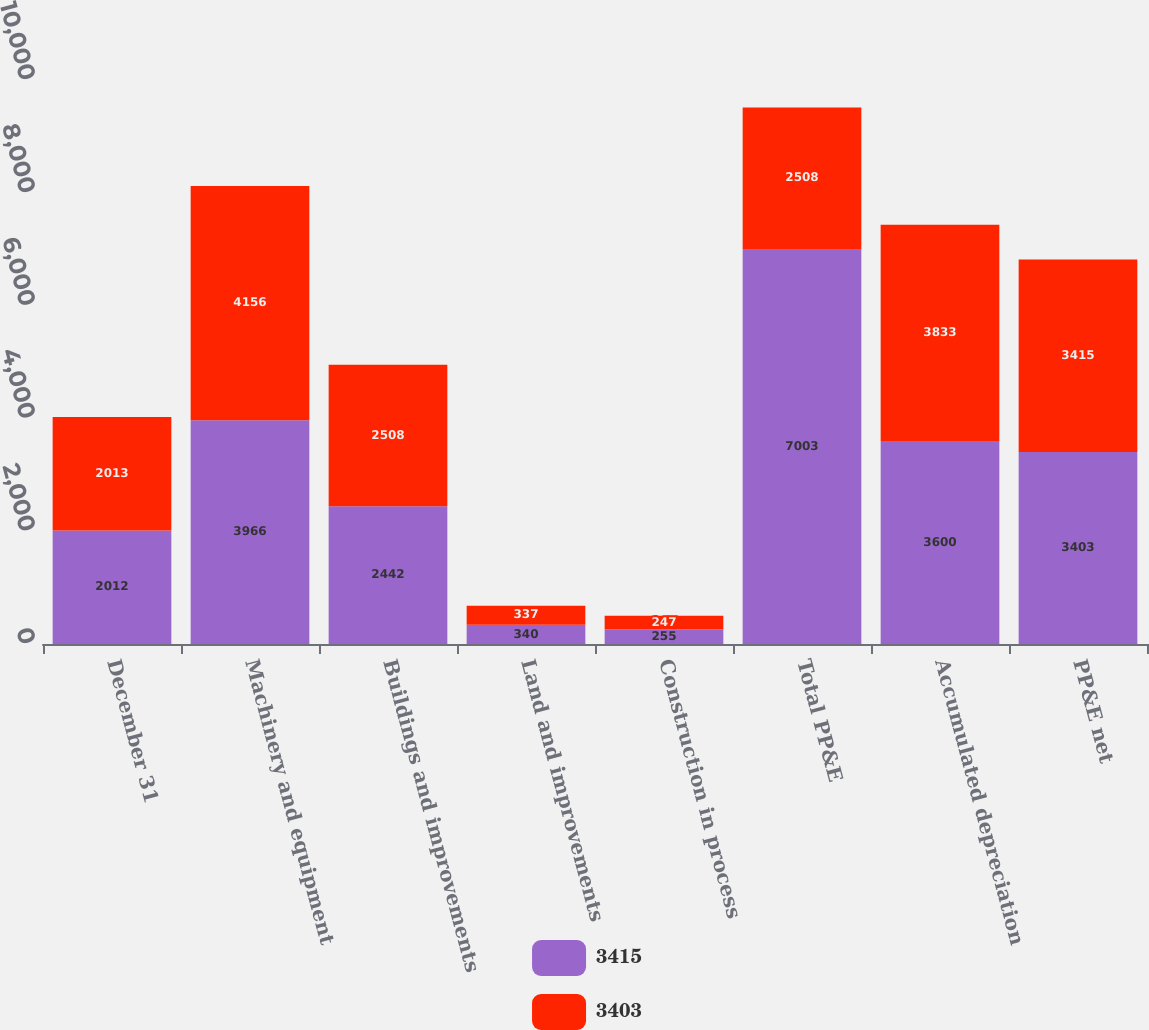Convert chart. <chart><loc_0><loc_0><loc_500><loc_500><stacked_bar_chart><ecel><fcel>December 31<fcel>Machinery and equipment<fcel>Buildings and improvements<fcel>Land and improvements<fcel>Construction in process<fcel>Total PP&E<fcel>Accumulated depreciation<fcel>PP&E net<nl><fcel>3415<fcel>2012<fcel>3966<fcel>2442<fcel>340<fcel>255<fcel>7003<fcel>3600<fcel>3403<nl><fcel>3403<fcel>2013<fcel>4156<fcel>2508<fcel>337<fcel>247<fcel>2508<fcel>3833<fcel>3415<nl></chart> 